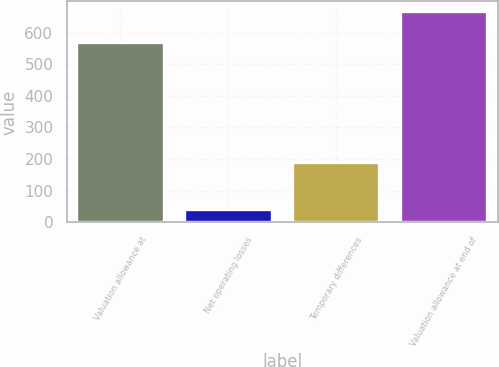Convert chart to OTSL. <chart><loc_0><loc_0><loc_500><loc_500><bar_chart><fcel>Valuation allowance at<fcel>Net operating losses<fcel>Temporary differences<fcel>Valuation allowance at end of<nl><fcel>567<fcel>39<fcel>186<fcel>666<nl></chart> 